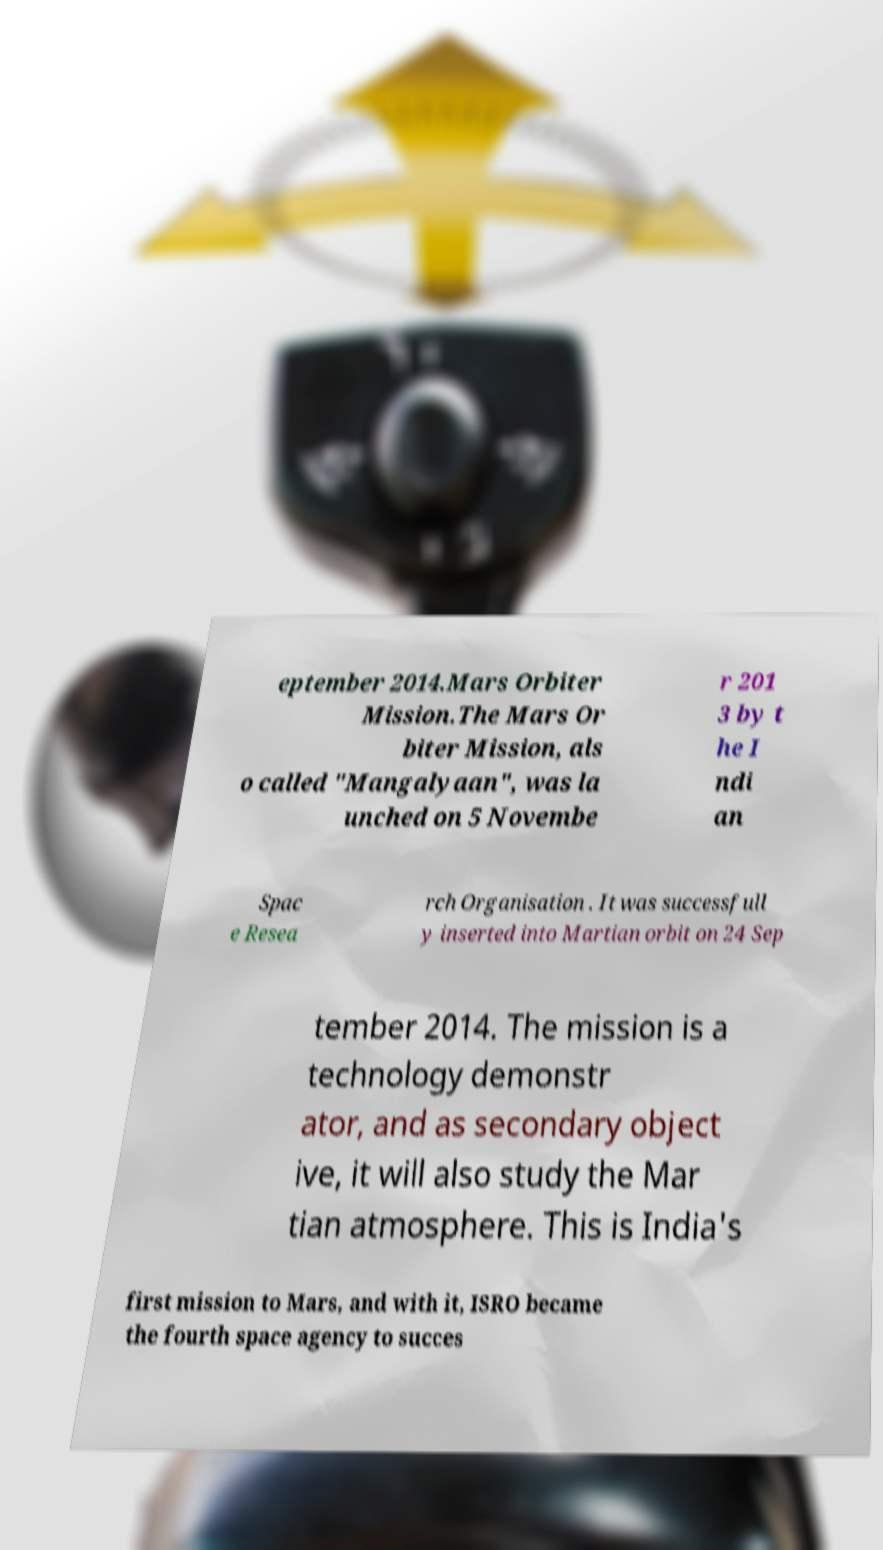Can you accurately transcribe the text from the provided image for me? eptember 2014.Mars Orbiter Mission.The Mars Or biter Mission, als o called "Mangalyaan", was la unched on 5 Novembe r 201 3 by t he I ndi an Spac e Resea rch Organisation . It was successfull y inserted into Martian orbit on 24 Sep tember 2014. The mission is a technology demonstr ator, and as secondary object ive, it will also study the Mar tian atmosphere. This is India's first mission to Mars, and with it, ISRO became the fourth space agency to succes 